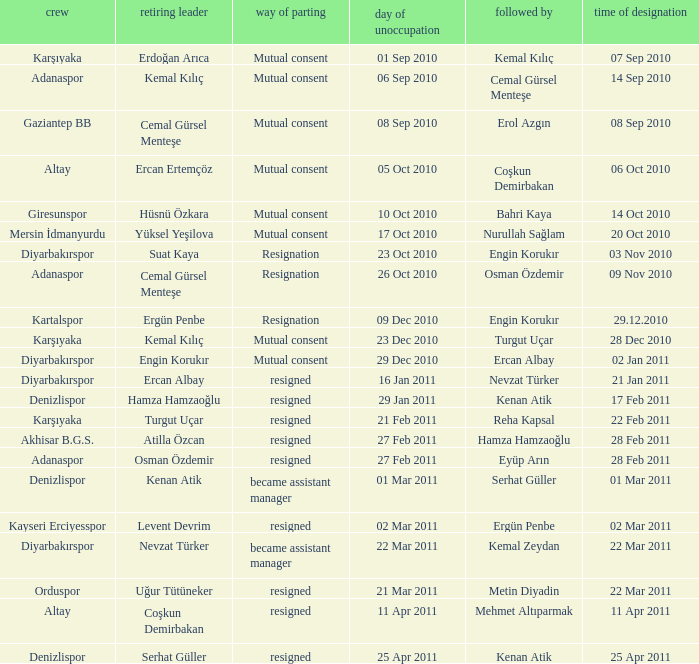Which team replaced their manager with Serhat Güller? Denizlispor. 